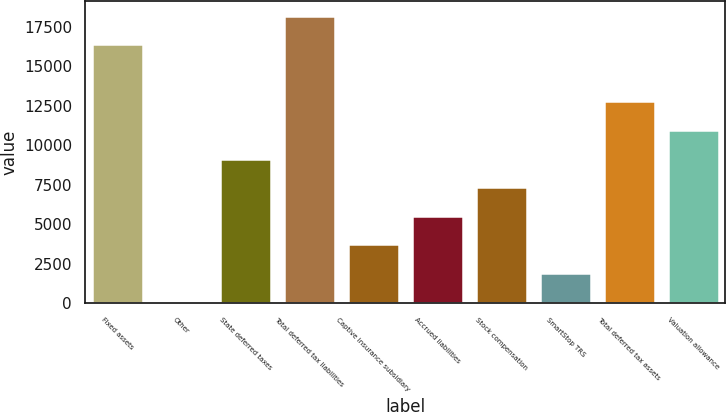<chart> <loc_0><loc_0><loc_500><loc_500><bar_chart><fcel>Fixed assets<fcel>Other<fcel>State deferred taxes<fcel>Total deferred tax liabilities<fcel>Captive insurance subsidiary<fcel>Accrued liabilities<fcel>Stock compensation<fcel>SmartStop TRS<fcel>Total deferred tax assets<fcel>Valuation allowance<nl><fcel>16391.7<fcel>108<fcel>9154.5<fcel>18201<fcel>3726.6<fcel>5535.9<fcel>7345.2<fcel>1917.3<fcel>12773.1<fcel>10963.8<nl></chart> 